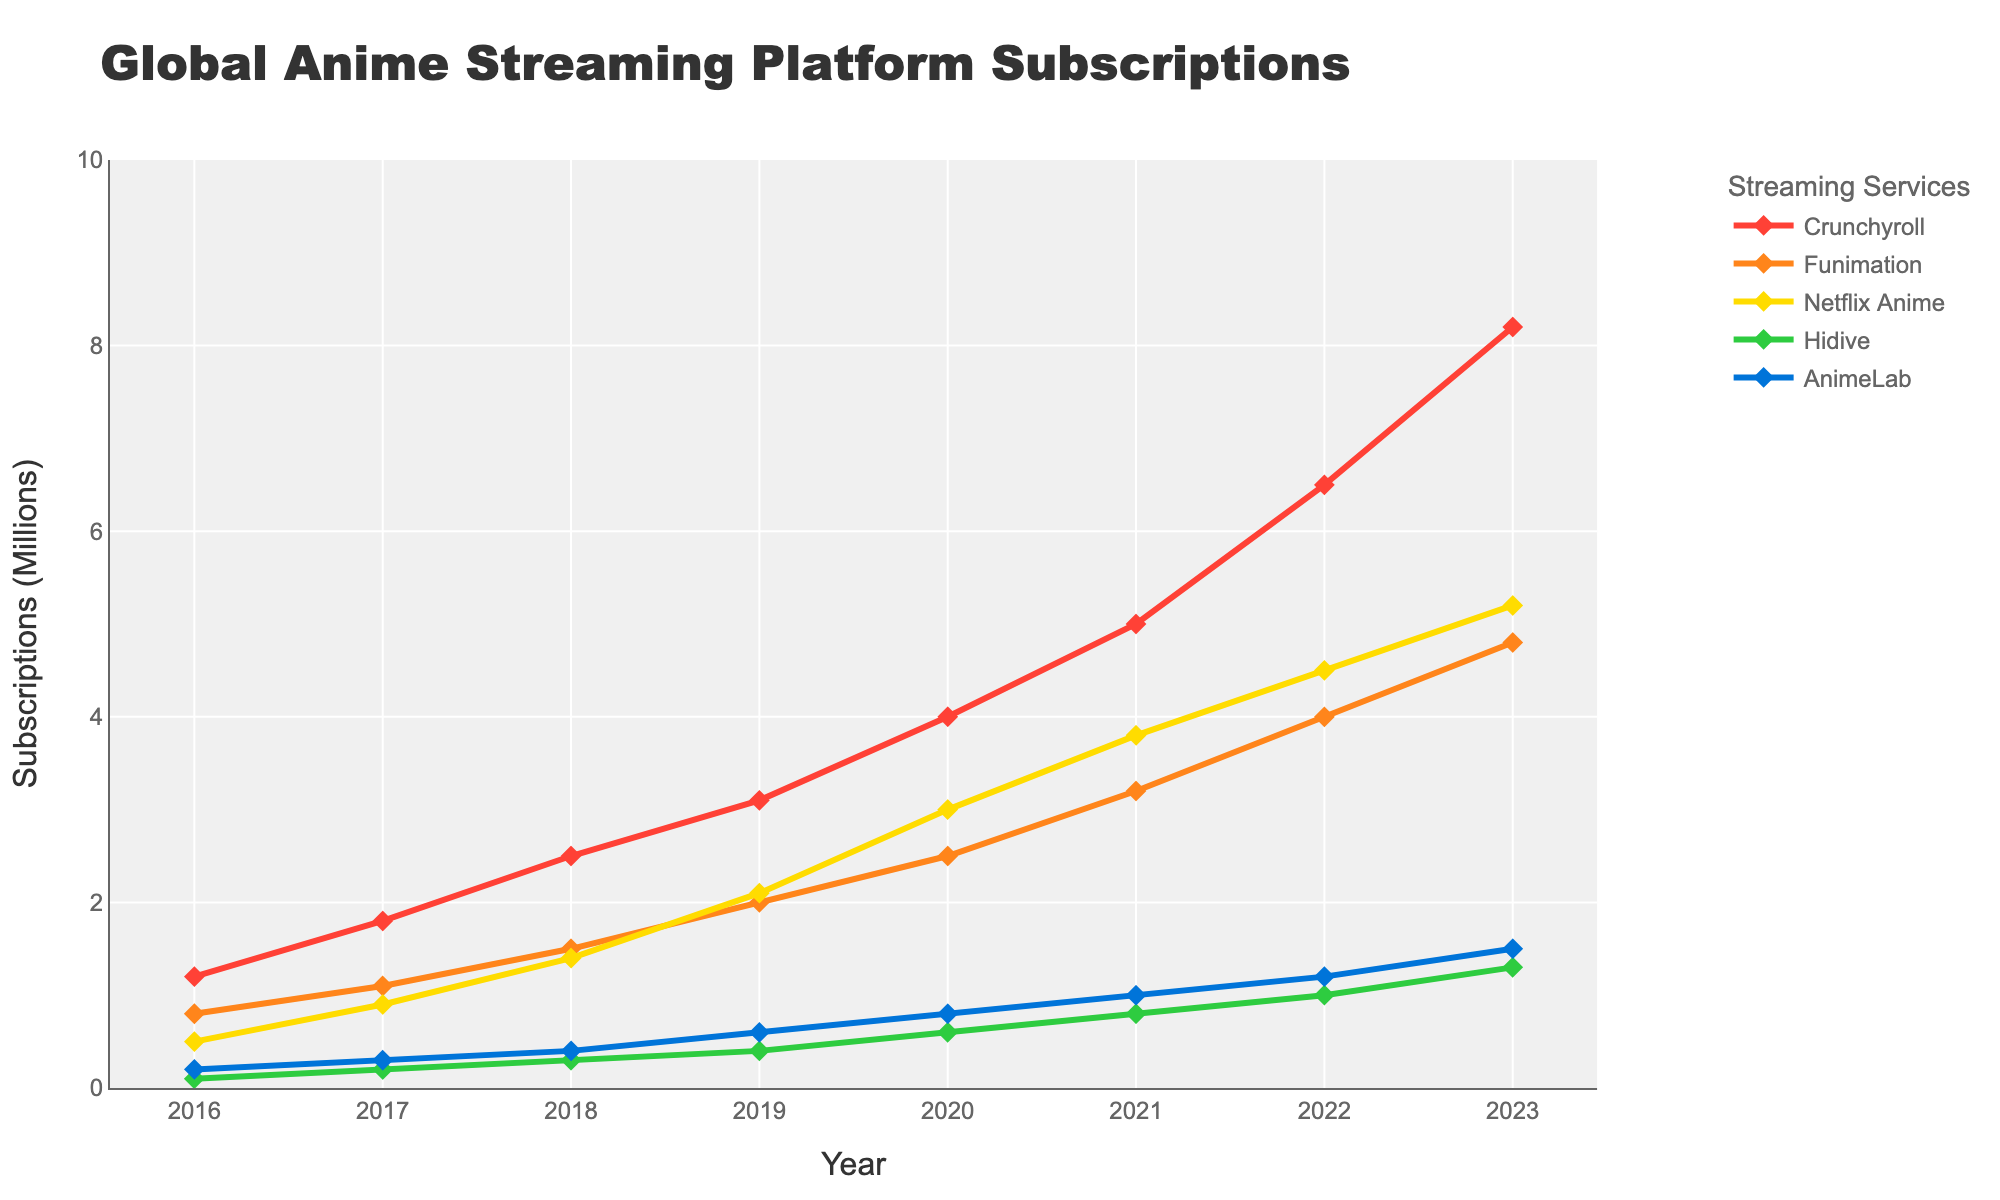What is the total number of subscriptions for all services combined in 2016? Sum the subscriptions for all services in 2016: Crunchyroll (1.2), Funimation (0.8), Netflix Anime (0.5), Hidive (0.1), and AnimeLab (0.2). Total = 1.2 + 0.8 + 0.5 + 0.1 + 0.2 = 2.8 million
Answer: 2.8 million Which streaming service had the highest increase in subscriptions between 2022 and 2023? Calculate the increase for each service from 2022 to 2023: Crunchyroll (8.2 - 6.5 = 1.7), Funimation (4.8 - 4.0 = 0.8), Netflix Anime (5.2 - 4.5 = 0.7), Hidive (1.3 - 1.0 = 0.3), AnimeLab (1.5 - 1.2 = 0.3). Crunchyroll had the highest increase (1.7 million).
Answer: Crunchyroll Between 2018 and 2020, which streaming service had the smallest growth in subscriptions? Calculate the growth for each service from 2018 to 2020: Crunchyroll (4.0 - 2.5 = 1.5), Funimation (2.5 - 1.5 = 1.0), Netflix Anime (3.0 - 1.4 = 1.6), Hidive (0.6 - 0.3 = 0.3), AnimeLab (0.8 - 0.4 = 0.4). Hidive had the smallest growth (0.3 million).
Answer: Hidive Which year did Netflix Anime surpass Funimation in subscriptions? Compare the subscriptions for each year to determine when Netflix Anime's values exceed Funimation's: In 2020, Netflix Anime has 3.0 million while Funimation has 2.5 million. This is the first year Netflix Anime surpasses Funimation.
Answer: 2020 What is the average yearly growth of Crunchyroll subscriptions from 2016 to 2023? Calculate the total growth for Crunchyroll: (8.2 - 1.2 = 7.0). Number of years is 2023 - 2016 = 7. Average growth per year = 7.0 / 7 ≈ 1.0 million per year.
Answer: 1.0 million per year In which year did the total subscriptions for all streaming services surpass 10 million? Calculate the yearly total subscriptions until the total surpasses 10 million: 
2016: 2.8 million 
2017: 4.3 million 
2018: 6.1 million 
2019: 8.2 million 
2020: 10.9 million. 
Total subscriptions surpass 10 million in 2020.
Answer: 2020 How many more subscriptions did Crunchyroll have than Netflix Anime in 2021? Compare Crunchyroll and Netflix Anime in 2021: Crunchyroll (5.0), Netflix Anime (3.8). Difference = 5.0 - 3.8 = 1.2 million.
Answer: 1.2 million Which year saw the largest single-year increase for Funimation? Calculate the yearly increase for Funimation and find the maximum: 
2016-2017: 1.1 - 0.8 = 0.3 
2017-2018: 1.5 - 1.1 = 0.4 
2018-2019: 2.0 - 1.5 = 0.5 
2019-2020: 2.5 - 2.0 = 0.5 
2020-2021: 3.2 - 2.5 = 0.7 
2021-2022: 4.0 - 3.2 = 0.8 
2022-2023: 4.8 - 4.0 = 0.8. 
The largest increase occurred in both 2021-2022 and 2022-2023 at 0.8 million each.
Answer: 2021-2022 and 2022-2023 